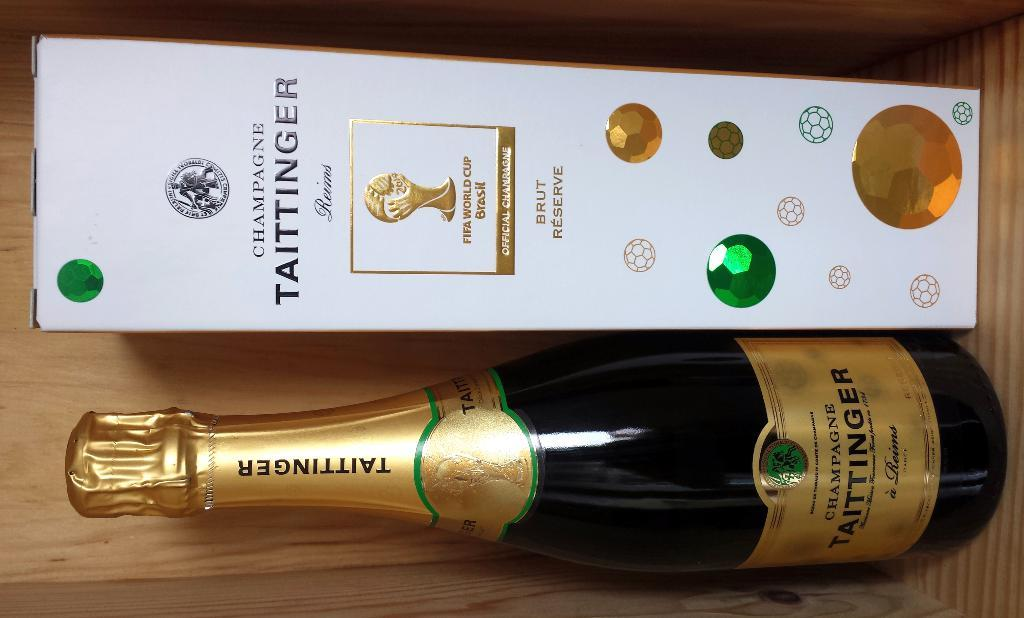<image>
Write a terse but informative summary of the picture. A bottle of Taittinger is placed next to its bejeweled box. 